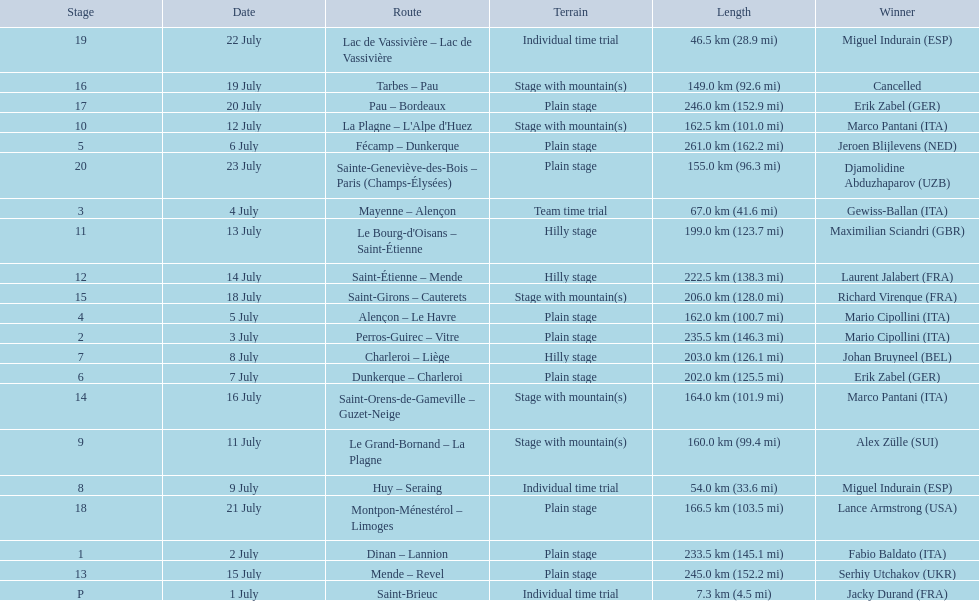What were the dates of the 1995 tour de france? 1 July, 2 July, 3 July, 4 July, 5 July, 6 July, 7 July, 8 July, 9 July, 11 July, 12 July, 13 July, 14 July, 15 July, 16 July, 18 July, 19 July, 20 July, 21 July, 22 July, 23 July. What was the length for july 8th? 203.0 km (126.1 mi). 